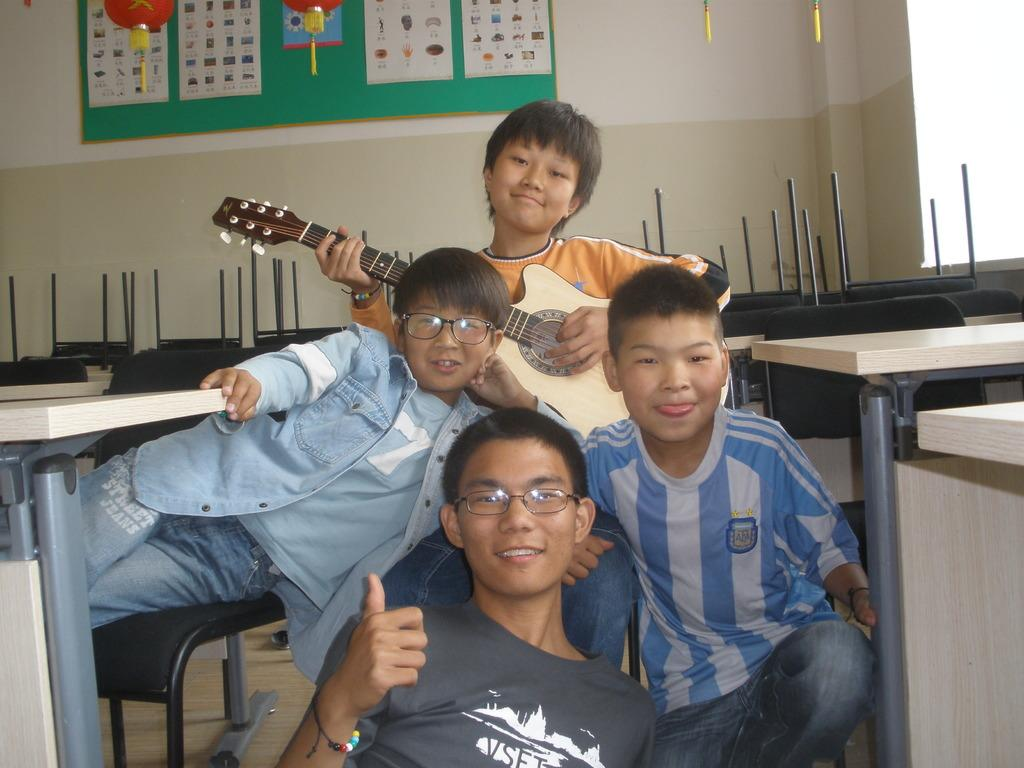What are the people in the image doing? The people in the image are sitting on the floor. Can you describe the man in the image? The man in the image is holding a guitar. How many ducks are present in the image? There are no ducks present in the image. What is the amount of visitors in the image? The image does not show any visitors, only people sitting on the floor and a man holding a guitar. 